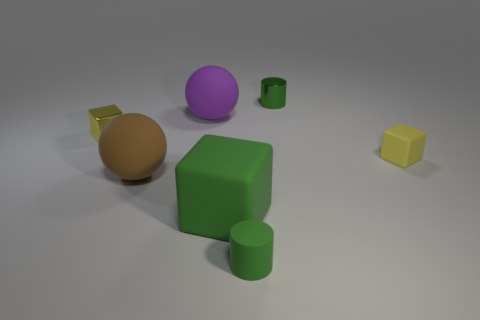Subtract all yellow rubber cubes. How many cubes are left? 2 Add 1 red cubes. How many objects exist? 8 Subtract all cylinders. How many objects are left? 5 Add 6 yellow things. How many yellow things are left? 8 Add 2 large brown rubber spheres. How many large brown rubber spheres exist? 3 Subtract 0 purple cylinders. How many objects are left? 7 Subtract all green rubber blocks. Subtract all matte cubes. How many objects are left? 4 